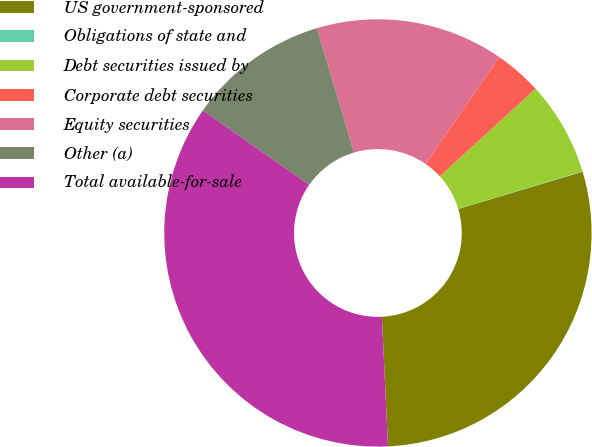Convert chart. <chart><loc_0><loc_0><loc_500><loc_500><pie_chart><fcel>US government-sponsored<fcel>Obligations of state and<fcel>Debt securities issued by<fcel>Corporate debt securities<fcel>Equity securities<fcel>Other (a)<fcel>Total available-for-sale<nl><fcel>28.87%<fcel>0.04%<fcel>7.13%<fcel>3.59%<fcel>14.22%<fcel>10.67%<fcel>35.47%<nl></chart> 